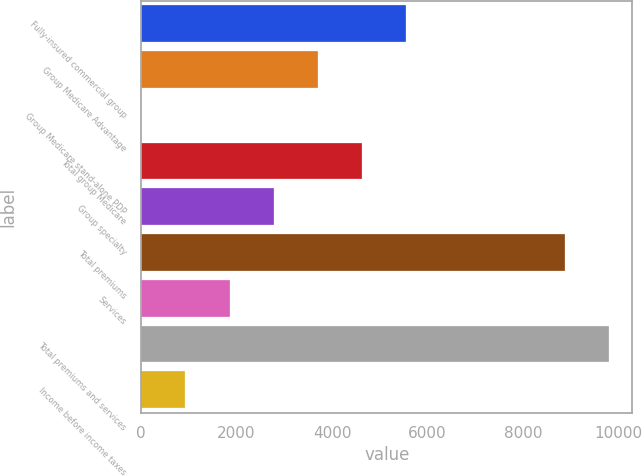Convert chart to OTSL. <chart><loc_0><loc_0><loc_500><loc_500><bar_chart><fcel>Fully-insured commercial group<fcel>Group Medicare Advantage<fcel>Group Medicare stand-alone PDP<fcel>Total group Medicare<fcel>Group specialty<fcel>Total premiums<fcel>Services<fcel>Total premiums and services<fcel>Income before income taxes<nl><fcel>5543<fcel>3698<fcel>8<fcel>4620.5<fcel>2775.5<fcel>8877<fcel>1853<fcel>9799.5<fcel>930.5<nl></chart> 